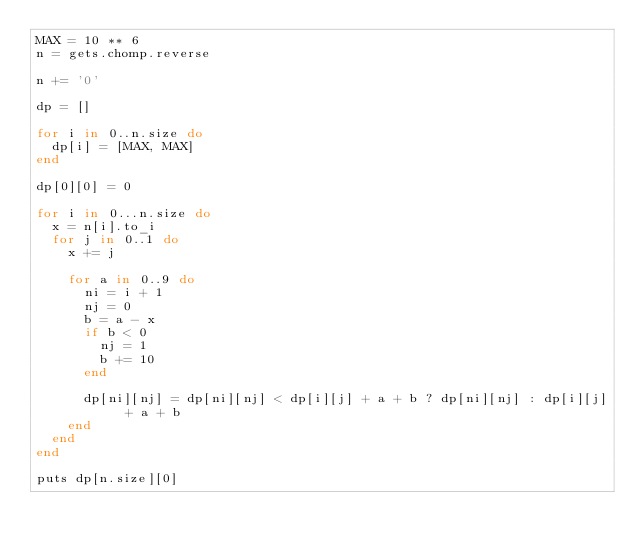<code> <loc_0><loc_0><loc_500><loc_500><_Ruby_>MAX = 10 ** 6
n = gets.chomp.reverse

n += '0'

dp = []

for i in 0..n.size do
  dp[i] = [MAX, MAX]
end

dp[0][0] = 0

for i in 0...n.size do
  x = n[i].to_i
  for j in 0..1 do
    x += j

    for a in 0..9 do
      ni = i + 1
      nj = 0
      b = a - x
      if b < 0
        nj = 1
        b += 10
      end

      dp[ni][nj] = dp[ni][nj] < dp[i][j] + a + b ? dp[ni][nj] : dp[i][j] + a + b
    end
  end
end

puts dp[n.size][0]
</code> 